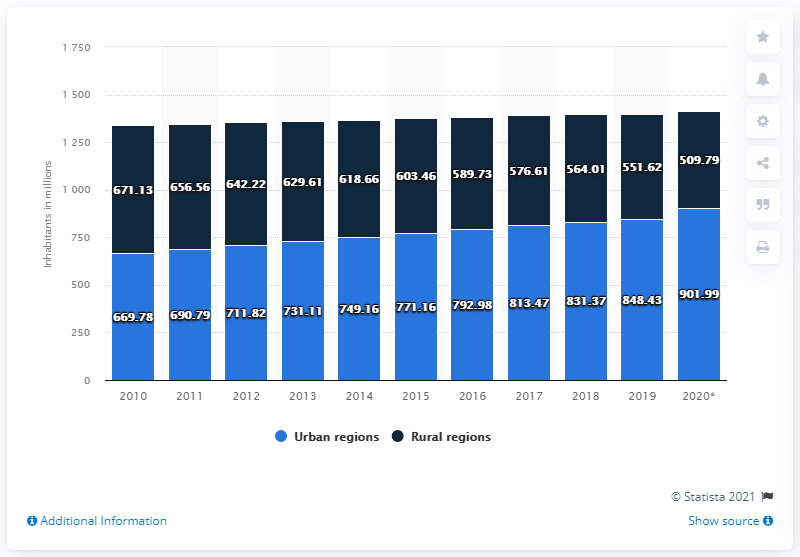Highlight a few significant elements in this photo. In 2020, it is estimated that approximately 901.99 people lived in urban areas of China. In 2020, there were approximately 509.79 million rural residents living in China. 